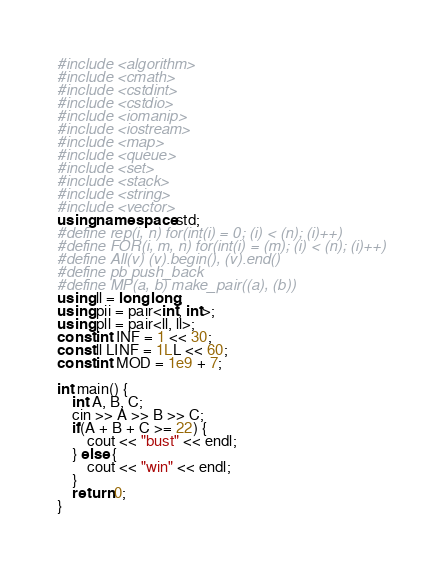<code> <loc_0><loc_0><loc_500><loc_500><_C++_>#include <algorithm>
#include <cmath>
#include <cstdint>
#include <cstdio>
#include <iomanip>
#include <iostream>
#include <map>
#include <queue>
#include <set>
#include <stack>
#include <string>
#include <vector>
using namespace std;
#define rep(i, n) for(int(i) = 0; (i) < (n); (i)++)
#define FOR(i, m, n) for(int(i) = (m); (i) < (n); (i)++)
#define All(v) (v).begin(), (v).end()
#define pb push_back
#define MP(a, b) make_pair((a), (b))
using ll = long long;
using pii = pair<int, int>;
using pll = pair<ll, ll>;
const int INF = 1 << 30;
const ll LINF = 1LL << 60;
const int MOD = 1e9 + 7;

int main() {
    int A, B, C;
    cin >> A >> B >> C;
    if(A + B + C >= 22) {
        cout << "bust" << endl;
    } else {
        cout << "win" << endl;
    }
    return 0;
}</code> 